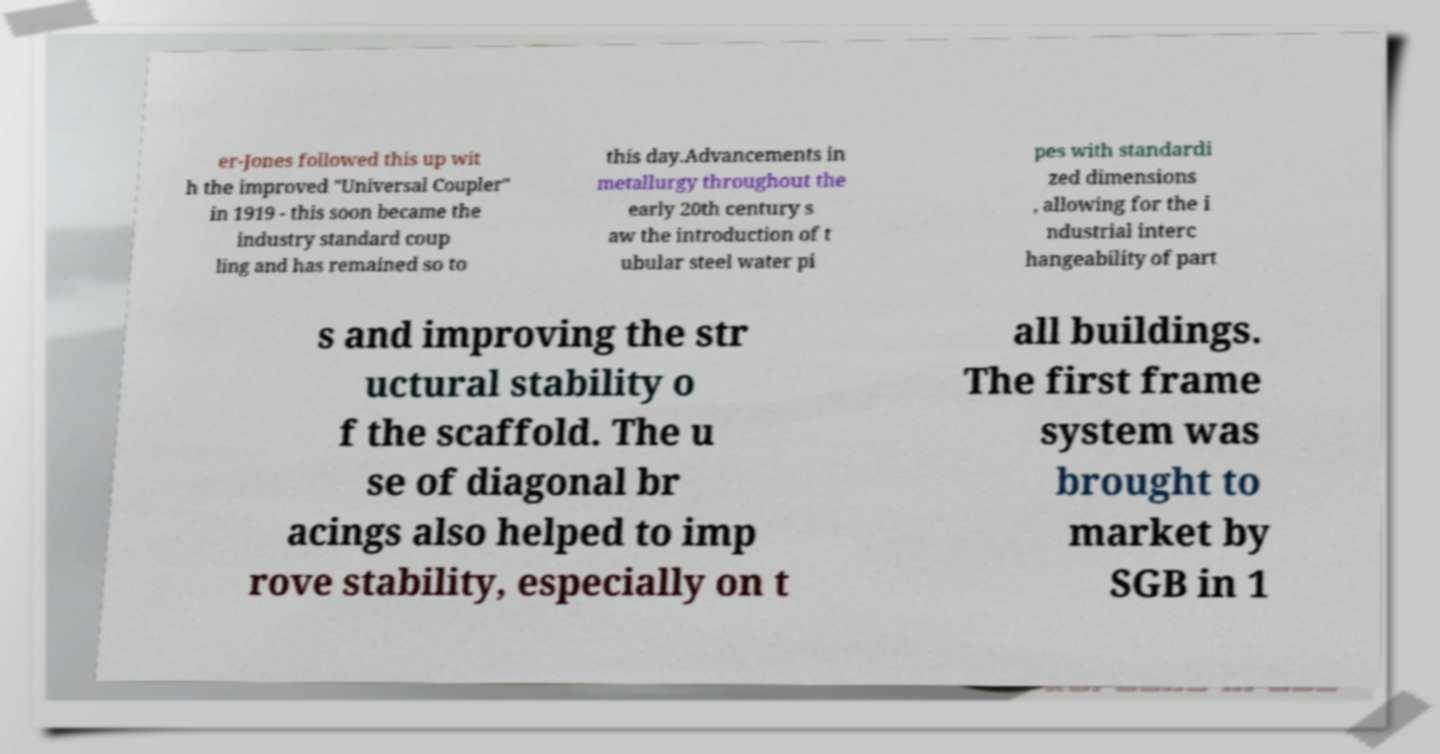Could you assist in decoding the text presented in this image and type it out clearly? er-Jones followed this up wit h the improved "Universal Coupler" in 1919 - this soon became the industry standard coup ling and has remained so to this day.Advancements in metallurgy throughout the early 20th century s aw the introduction of t ubular steel water pi pes with standardi zed dimensions , allowing for the i ndustrial interc hangeability of part s and improving the str uctural stability o f the scaffold. The u se of diagonal br acings also helped to imp rove stability, especially on t all buildings. The first frame system was brought to market by SGB in 1 